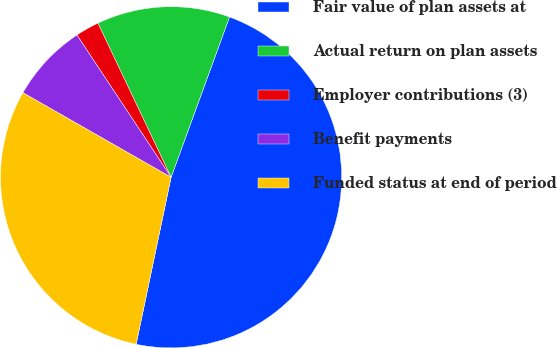Convert chart to OTSL. <chart><loc_0><loc_0><loc_500><loc_500><pie_chart><fcel>Fair value of plan assets at<fcel>Actual return on plan assets<fcel>Employer contributions (3)<fcel>Benefit payments<fcel>Funded status at end of period<nl><fcel>47.72%<fcel>12.62%<fcel>2.25%<fcel>7.44%<fcel>29.97%<nl></chart> 